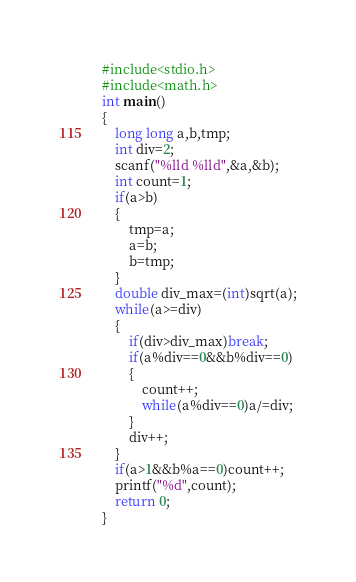Convert code to text. <code><loc_0><loc_0><loc_500><loc_500><_C_>#include<stdio.h>
#include<math.h>
int main()
{
    long long a,b,tmp;
    int div=2;
    scanf("%lld %lld",&a,&b);
    int count=1;
    if(a>b)
    {
        tmp=a;
        a=b;
        b=tmp;
    }
    double div_max=(int)sqrt(a);
    while(a>=div)
    {   
        if(div>div_max)break;
        if(a%div==0&&b%div==0)
        {
            count++;
            while(a%div==0)a/=div;
        }
        div++;
    }
    if(a>1&&b%a==0)count++;
    printf("%d",count);
    return 0;
}</code> 